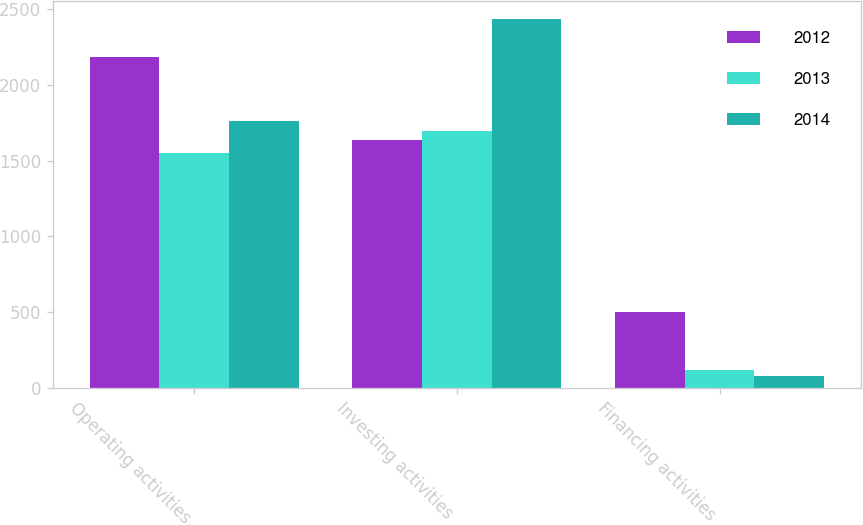Convert chart. <chart><loc_0><loc_0><loc_500><loc_500><stacked_bar_chart><ecel><fcel>Operating activities<fcel>Investing activities<fcel>Financing activities<nl><fcel>2012<fcel>2186.4<fcel>1638<fcel>504.3<nl><fcel>2013<fcel>1553.1<fcel>1697<fcel>115.4<nl><fcel>2014<fcel>1765.1<fcel>2435.2<fcel>78.4<nl></chart> 